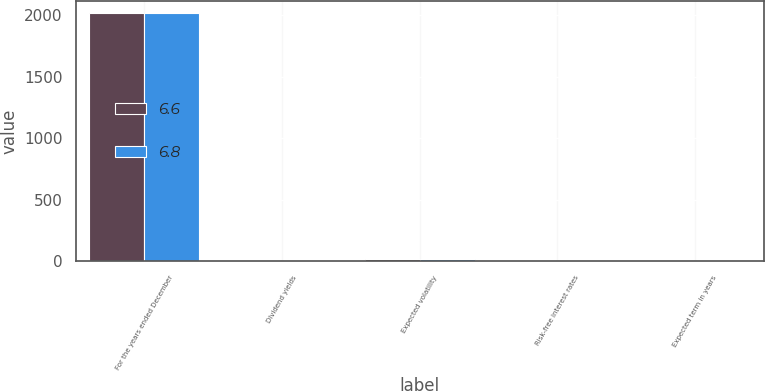<chart> <loc_0><loc_0><loc_500><loc_500><stacked_bar_chart><ecel><fcel>For the years ended December<fcel>Dividend yields<fcel>Expected volatility<fcel>Risk-free interest rates<fcel>Expected term in years<nl><fcel>6.6<fcel>2018<fcel>2.4<fcel>16.6<fcel>2.8<fcel>6.6<nl><fcel>6.8<fcel>2017<fcel>2.4<fcel>17.2<fcel>2.2<fcel>6.8<nl></chart> 